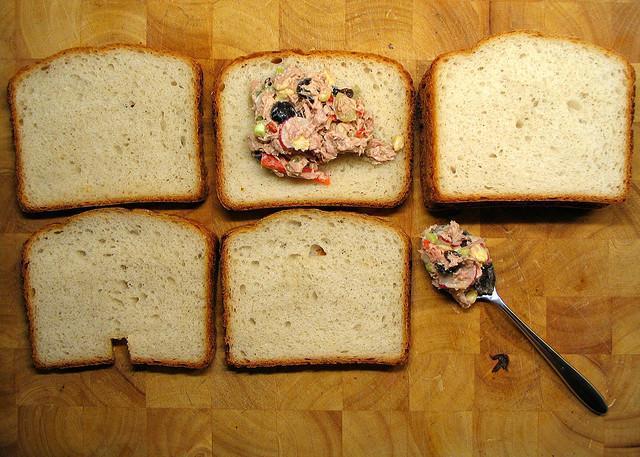How many pieces of bread have food on it?
Give a very brief answer. 1. How many sandwiches are there?
Give a very brief answer. 3. 